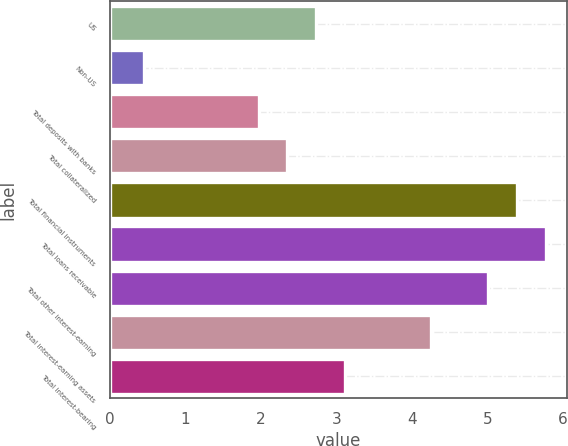Convert chart to OTSL. <chart><loc_0><loc_0><loc_500><loc_500><bar_chart><fcel>US<fcel>Non-US<fcel>Total deposits with banks<fcel>Total collateralized<fcel>Total financial instruments<fcel>Total loans receivable<fcel>Total other interest-earning<fcel>Total interest-earning assets<fcel>Total interest-bearing<nl><fcel>2.73<fcel>0.45<fcel>1.97<fcel>2.35<fcel>5.39<fcel>5.77<fcel>5.01<fcel>4.25<fcel>3.11<nl></chart> 